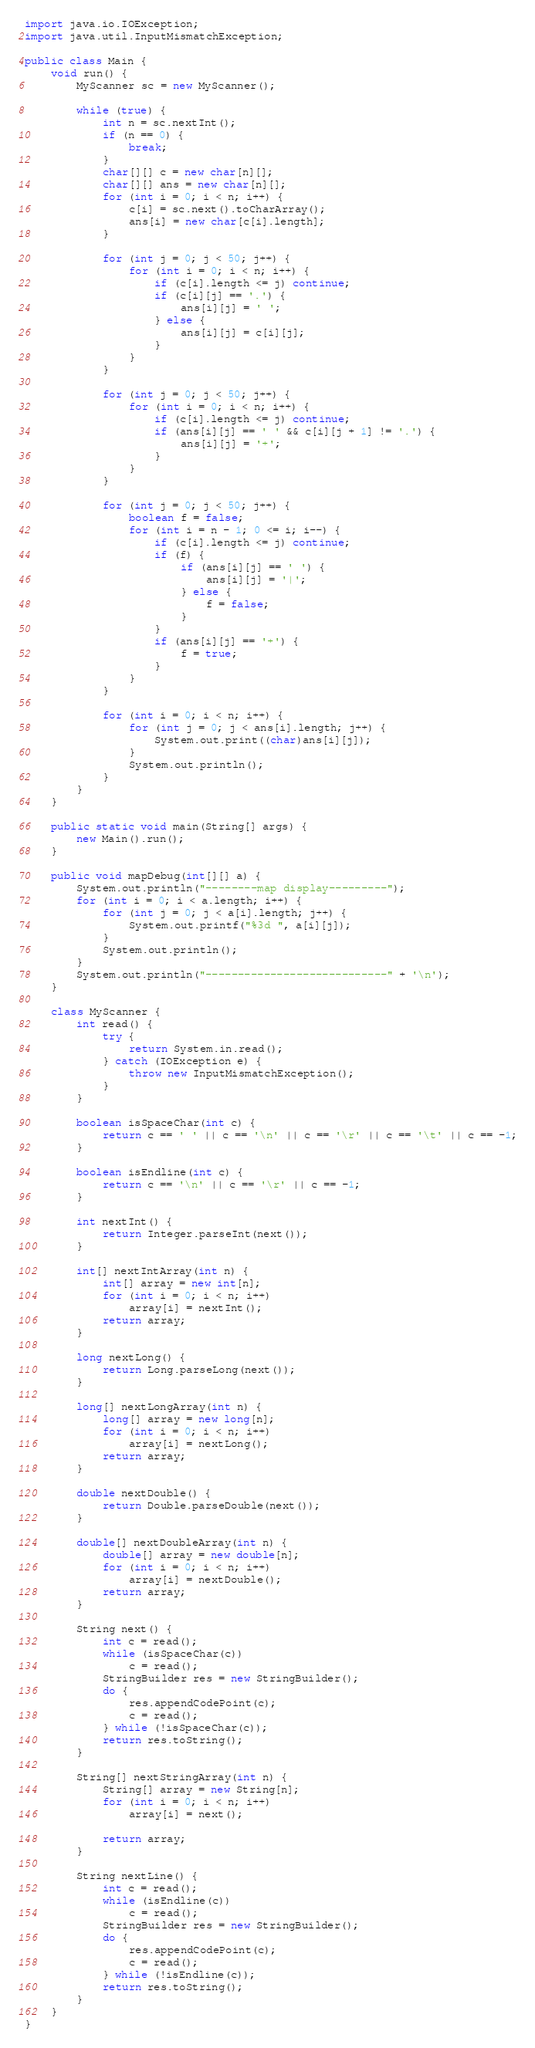Convert code to text. <code><loc_0><loc_0><loc_500><loc_500><_Java_>import java.io.IOException;
import java.util.InputMismatchException;

public class Main {
	void run() {
		MyScanner sc = new MyScanner();

		while (true) {
			int n = sc.nextInt();
			if (n == 0) {
				break;
			}
			char[][] c = new char[n][];
			char[][] ans = new char[n][];
			for (int i = 0; i < n; i++) {
				c[i] = sc.next().toCharArray();
				ans[i] = new char[c[i].length];
			}

			for (int j = 0; j < 50; j++) {
				for (int i = 0; i < n; i++) {
					if (c[i].length <= j) continue;
					if (c[i][j] == '.') {
						ans[i][j] = ' ';
					} else {
						ans[i][j] = c[i][j];
					}
				}
			}

			for (int j = 0; j < 50; j++) {
				for (int i = 0; i < n; i++) {
					if (c[i].length <= j) continue;
					if (ans[i][j] == ' ' && c[i][j + 1] != '.') {
						ans[i][j] = '+';
					}
				}
			}

			for (int j = 0; j < 50; j++) {
				boolean f = false;
				for (int i = n - 1; 0 <= i; i--) {
					if (c[i].length <= j) continue;
					if (f) {
						if (ans[i][j] == ' ') {
							ans[i][j] = '|';
						} else {
							f = false;
						}
					}
					if (ans[i][j] == '+') {
						f = true;
					}
				}
			}

			for (int i = 0; i < n; i++) {
				for (int j = 0; j < ans[i].length; j++) {
					System.out.print((char)ans[i][j]);
				}
				System.out.println();
			}
		}
	}

	public static void main(String[] args) {
		new Main().run();
	}

	public void mapDebug(int[][] a) {
		System.out.println("--------map display---------");
		for (int i = 0; i < a.length; i++) {
			for (int j = 0; j < a[i].length; j++) {
				System.out.printf("%3d ", a[i][j]);
			}
			System.out.println();
		}
		System.out.println("----------------------------" + '\n');
	}

	class MyScanner {
		int read() {
			try {
				return System.in.read();
			} catch (IOException e) {
				throw new InputMismatchException();
			}
		}

		boolean isSpaceChar(int c) {
			return c == ' ' || c == '\n' || c == '\r' || c == '\t' || c == -1;
		}

		boolean isEndline(int c) {
			return c == '\n' || c == '\r' || c == -1;
		}

		int nextInt() {
			return Integer.parseInt(next());
		}

		int[] nextIntArray(int n) {
			int[] array = new int[n];
			for (int i = 0; i < n; i++)
				array[i] = nextInt();
			return array;
		}

		long nextLong() {
			return Long.parseLong(next());
		}

		long[] nextLongArray(int n) {
			long[] array = new long[n];
			for (int i = 0; i < n; i++)
				array[i] = nextLong();
			return array;
		}

		double nextDouble() {
			return Double.parseDouble(next());
		}

		double[] nextDoubleArray(int n) {
			double[] array = new double[n];
			for (int i = 0; i < n; i++)
				array[i] = nextDouble();
			return array;
		}

		String next() {
			int c = read();
			while (isSpaceChar(c))
				c = read();
			StringBuilder res = new StringBuilder();
			do {
				res.appendCodePoint(c);
				c = read();
			} while (!isSpaceChar(c));
			return res.toString();
		}

		String[] nextStringArray(int n) {
			String[] array = new String[n];
			for (int i = 0; i < n; i++)
				array[i] = next();

			return array;
		}

		String nextLine() {
			int c = read();
			while (isEndline(c))
				c = read();
			StringBuilder res = new StringBuilder();
			do {
				res.appendCodePoint(c);
				c = read();
			} while (!isEndline(c));
			return res.toString();
		}
	}
}</code> 